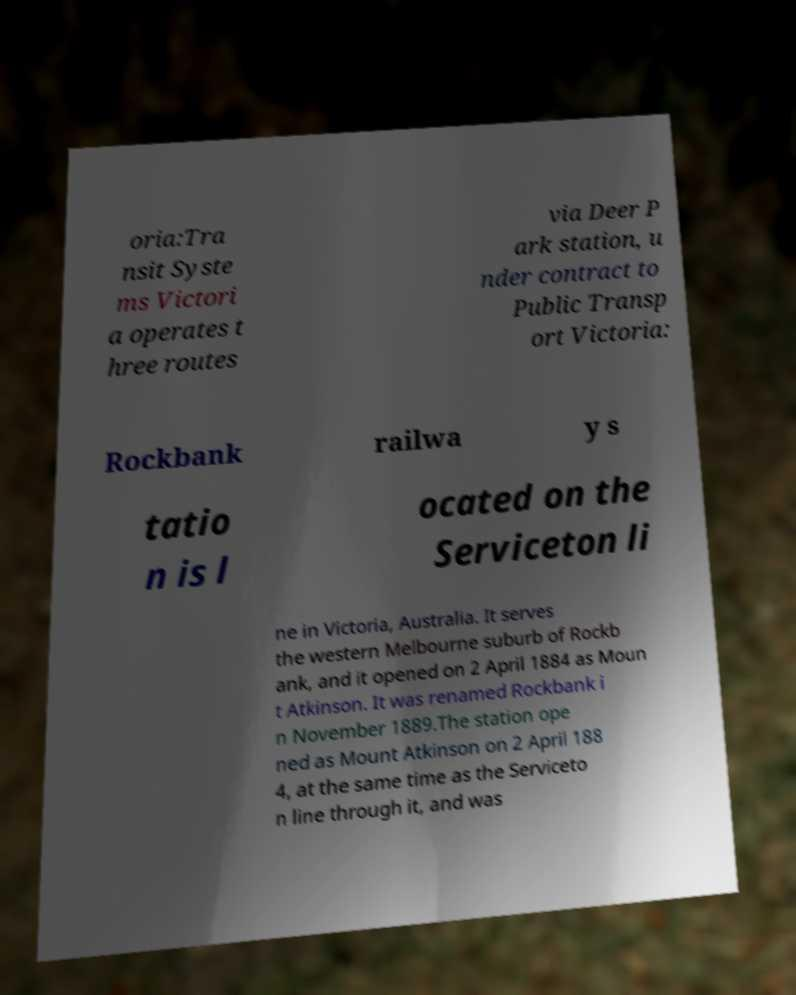There's text embedded in this image that I need extracted. Can you transcribe it verbatim? oria:Tra nsit Syste ms Victori a operates t hree routes via Deer P ark station, u nder contract to Public Transp ort Victoria: Rockbank railwa y s tatio n is l ocated on the Serviceton li ne in Victoria, Australia. It serves the western Melbourne suburb of Rockb ank, and it opened on 2 April 1884 as Moun t Atkinson. It was renamed Rockbank i n November 1889.The station ope ned as Mount Atkinson on 2 April 188 4, at the same time as the Serviceto n line through it, and was 